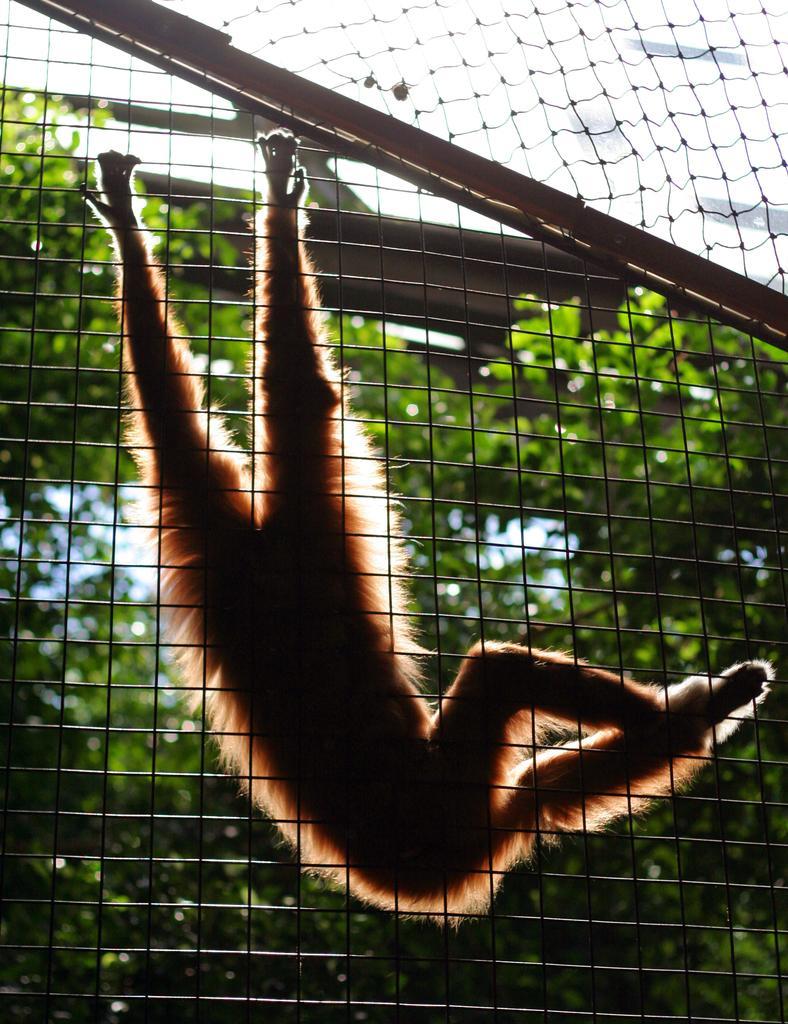Could you give a brief overview of what you see in this image? There is an animal which is hanging to the fence. And it is also looking like a cage. In the background we can observe trees. The animal is looking like a monkey with two hands and two legs. 